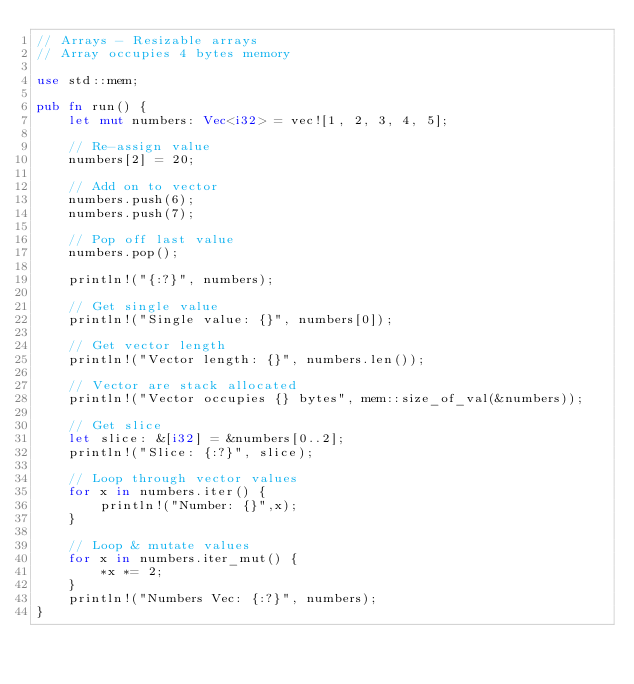<code> <loc_0><loc_0><loc_500><loc_500><_Rust_>// Arrays - Resizable arrays
// Array occupies 4 bytes memory

use std::mem;

pub fn run() {
    let mut numbers: Vec<i32> = vec![1, 2, 3, 4, 5];

    // Re-assign value
    numbers[2] = 20;

    // Add on to vector
    numbers.push(6);
    numbers.push(7);

    // Pop off last value
    numbers.pop();

    println!("{:?}", numbers);

    // Get single value
    println!("Single value: {}", numbers[0]);

    // Get vector length
    println!("Vector length: {}", numbers.len());

    // Vector are stack allocated 
    println!("Vector occupies {} bytes", mem::size_of_val(&numbers));

    // Get slice
    let slice: &[i32] = &numbers[0..2];
    println!("Slice: {:?}", slice);

    // Loop through vector values
    for x in numbers.iter() {
        println!("Number: {}",x);
    }

    // Loop & mutate values
    for x in numbers.iter_mut() {
        *x *= 2;
    }
    println!("Numbers Vec: {:?}", numbers);
}</code> 